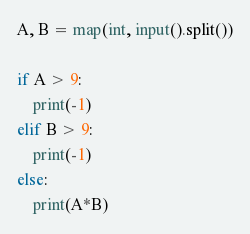<code> <loc_0><loc_0><loc_500><loc_500><_Python_>A, B = map(int, input().split())

if A > 9:
	print(-1)
elif B > 9:
	print(-1)
else:
	print(A*B)</code> 